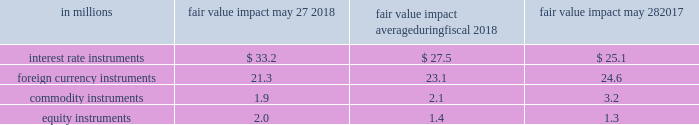Course of business , we actively manage our exposure to these market risks by entering into various hedging transactions , authorized under established policies that place clear controls on these activities .
The counterparties in these transactions are generally highly rated institutions .
We establish credit limits for each counterparty .
Our hedging transactions include but are not limited to a variety of derivative financial instruments .
For information on interest rate , foreign exchange , commodity price , and equity instrument risk , please see note 7 to the consolidated financial statements in item 8 of this report .
Value at risk the estimates in the table below are intended to measure the maximum potential fair value we could lose in one day from adverse changes in market interest rates , foreign exchange rates , commodity prices , and equity prices under normal market conditions .
A monte carlo value-at-risk ( var ) methodology was used to quantify the market risk for our exposures .
The models assumed normal market conditions and used a 95 percent confidence level .
The var calculation used historical interest and foreign exchange rates , and commodity and equity prices from the past year to estimate the potential volatility and correlation of these rates in the future .
The market data were drawn from the riskmetrics 2122 data set .
The calculations are not intended to represent actual losses in fair value that we expect to incur .
Further , since the hedging instrument ( the derivative ) inversely correlates with the underlying exposure , we would expect that any loss or gain in the fair value of our derivatives would be generally offset by an increase or decrease in the fair value of the underlying exposure .
The positions included in the calculations were : debt ; investments ; interest rate swaps ; foreign exchange forwards ; commodity swaps , futures , and options ; and equity instruments .
The calculations do not include the underlying foreign exchange and commodities or equity-related positions that are offset by these market-risk-sensitive instruments .
The table below presents the estimated maximum potential var arising from a one-day loss in fair value for our interest rate , foreign currency , commodity , and equity market-risk-sensitive instruments outstanding as of may 27 , 2018 and may 28 , 2017 , and the average fair value impact during the year ended may 27 , 2018. .

What is the net change in interest rate instruments from 2017 to 2018? 
Computations: (33.2 - 25.1)
Answer: 8.1. 